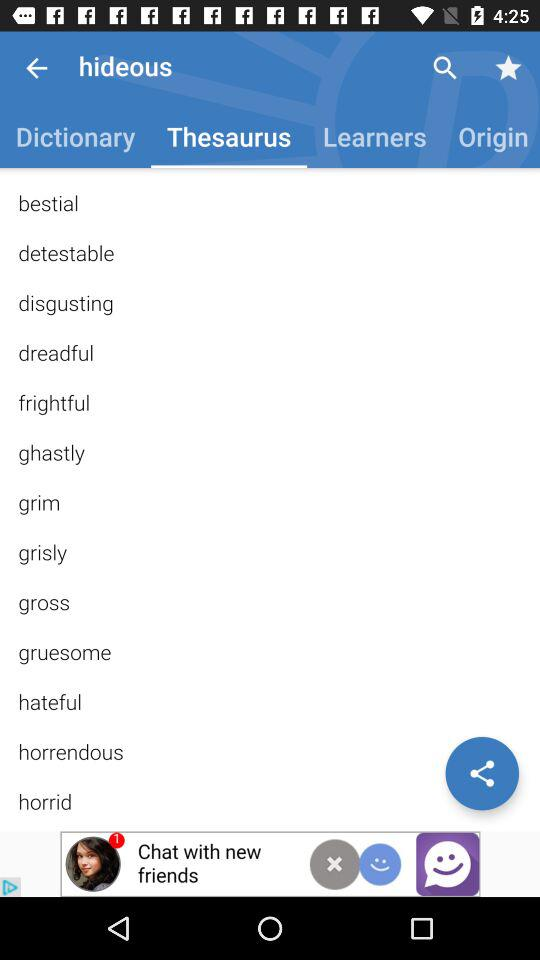What is the text entered in the search bar? The entered text is "hideous". 